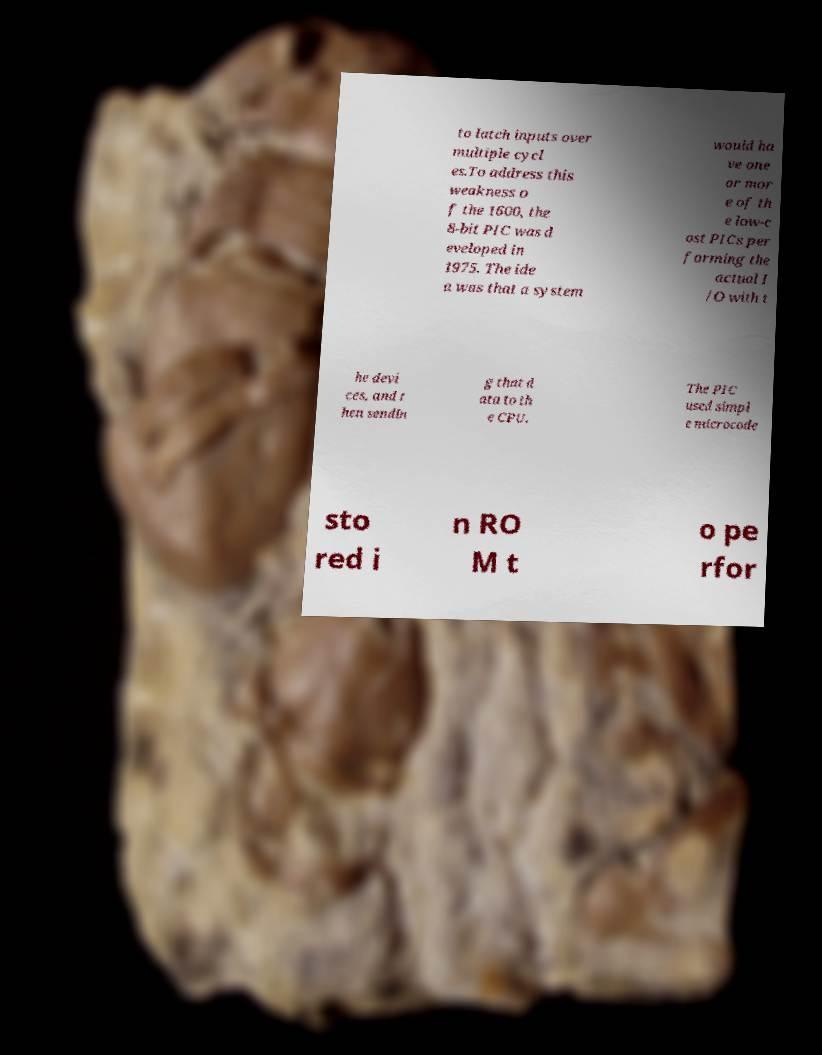Can you accurately transcribe the text from the provided image for me? to latch inputs over multiple cycl es.To address this weakness o f the 1600, the 8-bit PIC was d eveloped in 1975. The ide a was that a system would ha ve one or mor e of th e low-c ost PICs per forming the actual I /O with t he devi ces, and t hen sendin g that d ata to th e CPU. The PIC used simpl e microcode sto red i n RO M t o pe rfor 